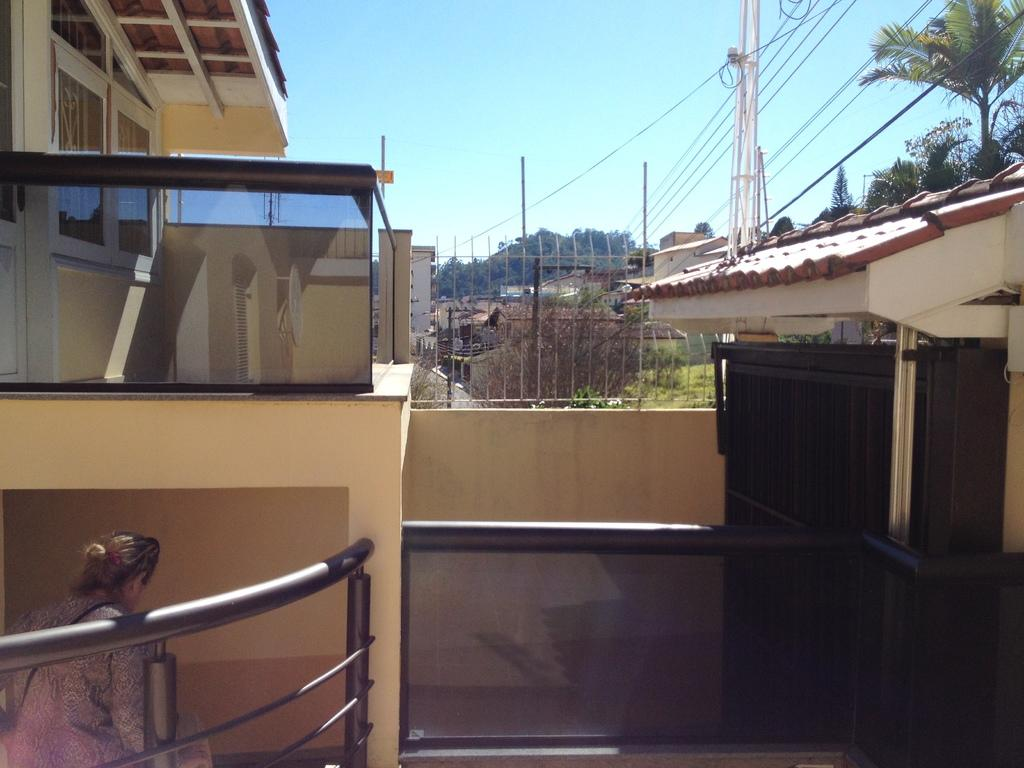What type of structures can be seen in the image? There are buildings in the image. What else can be seen in the image besides buildings? There are poles, trees, wires, and the sky visible in the image. Can you describe the person in the image? There is a person in the image, but no specific details about their appearance or behavior are provided. What type of watch is the person wearing in the image? There is no watch visible in the image, as no specific details about the person's appearance or clothing are provided. 